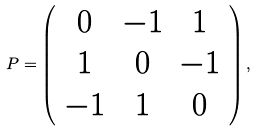<formula> <loc_0><loc_0><loc_500><loc_500>P = \left ( \begin{array} { c c c } 0 & - 1 & 1 \\ 1 & 0 & - 1 \\ - 1 & 1 & 0 \end{array} \right ) ,</formula> 